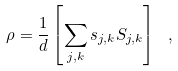<formula> <loc_0><loc_0><loc_500><loc_500>\rho = \frac { 1 } { d } \left [ \sum _ { j , k } s _ { j , k } S _ { j , k } \right ] \ ,</formula> 